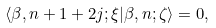<formula> <loc_0><loc_0><loc_500><loc_500>\langle \beta , n + 1 + 2 j ; \xi | \beta , n ; \zeta \rangle = 0 ,</formula> 